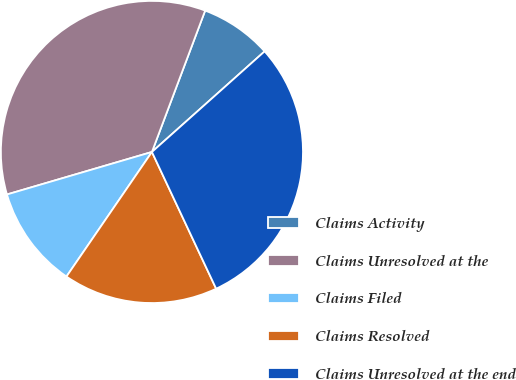<chart> <loc_0><loc_0><loc_500><loc_500><pie_chart><fcel>Claims Activity<fcel>Claims Unresolved at the<fcel>Claims Filed<fcel>Claims Resolved<fcel>Claims Unresolved at the end<nl><fcel>7.67%<fcel>35.27%<fcel>10.89%<fcel>16.56%<fcel>29.61%<nl></chart> 